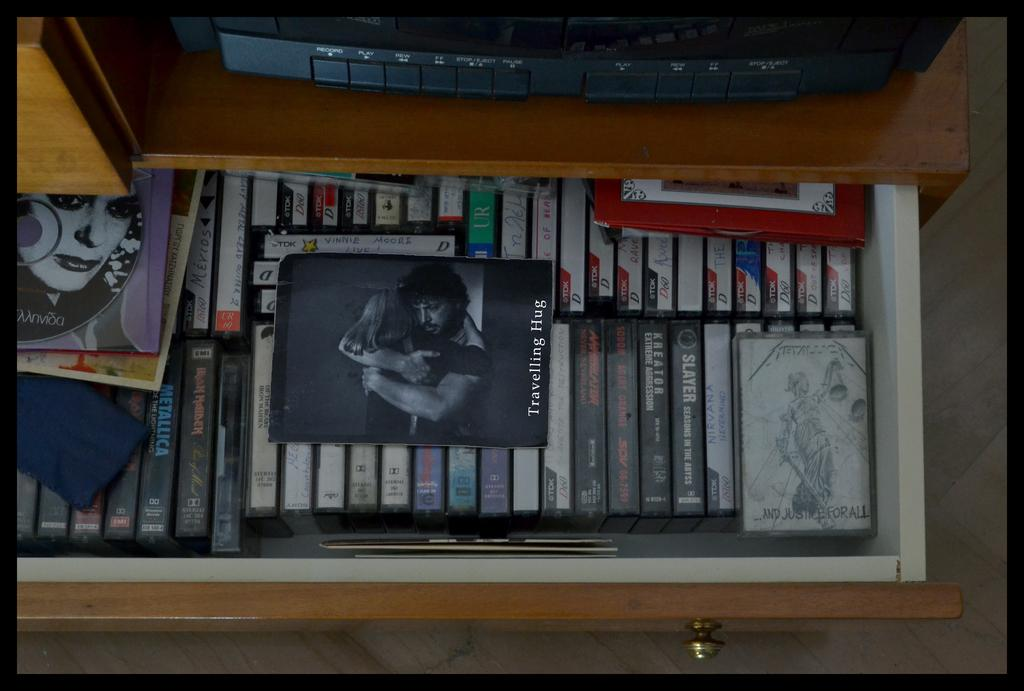<image>
Give a short and clear explanation of the subsequent image. several cassette tapes are under the travelling hug card 